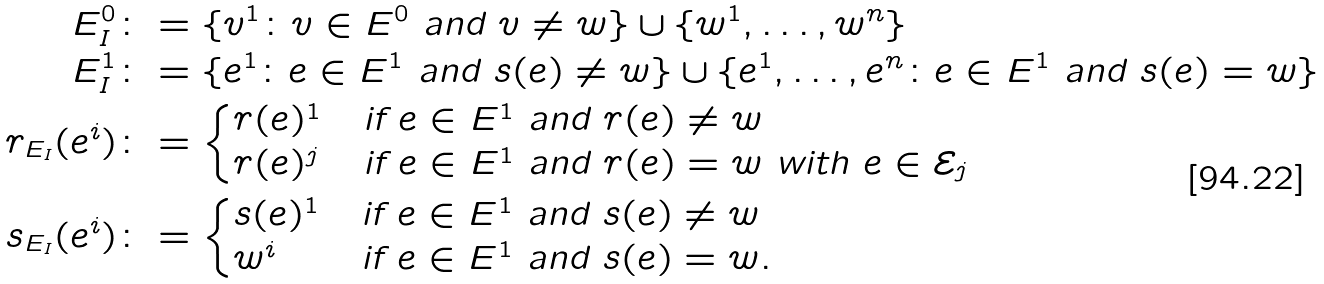<formula> <loc_0><loc_0><loc_500><loc_500>E _ { I } ^ { 0 } & \colon = \{ v ^ { 1 } \colon \text {$v \in E^{0}$ and $v \neq w$} \} \cup \{ w ^ { 1 } , \dots , w ^ { n } \} \\ E _ { I } ^ { 1 } & \colon = \{ e ^ { 1 } \colon \text {$e \in E^{1}$ and $s(e) \neq w$} \} \cup \{ e ^ { 1 } , \dots , e ^ { n } \colon e \in E ^ { 1 } \text { and } s ( e ) = w \} \\ r _ { E _ { I } } ( e ^ { i } ) & \colon = \begin{cases} r ( e ) ^ { 1 } & \text {if $e \in E^{1}$ and $r(e) \neq w$} \\ r ( e ) ^ { j } & \text {if $e \in E^{1}$ and $r(e) = w$ with $e \in \mathcal{E}_{j}$} \end{cases} \\ s _ { E _ { I } } ( e ^ { i } ) & \colon = \begin{cases} s ( e ) ^ { 1 } & \text {if $e \in E^{1}$ and $s(e) \neq w$} \\ w ^ { i } & \text {if $e \in E^{1}$ and $s(e) = w$} . \end{cases}</formula> 